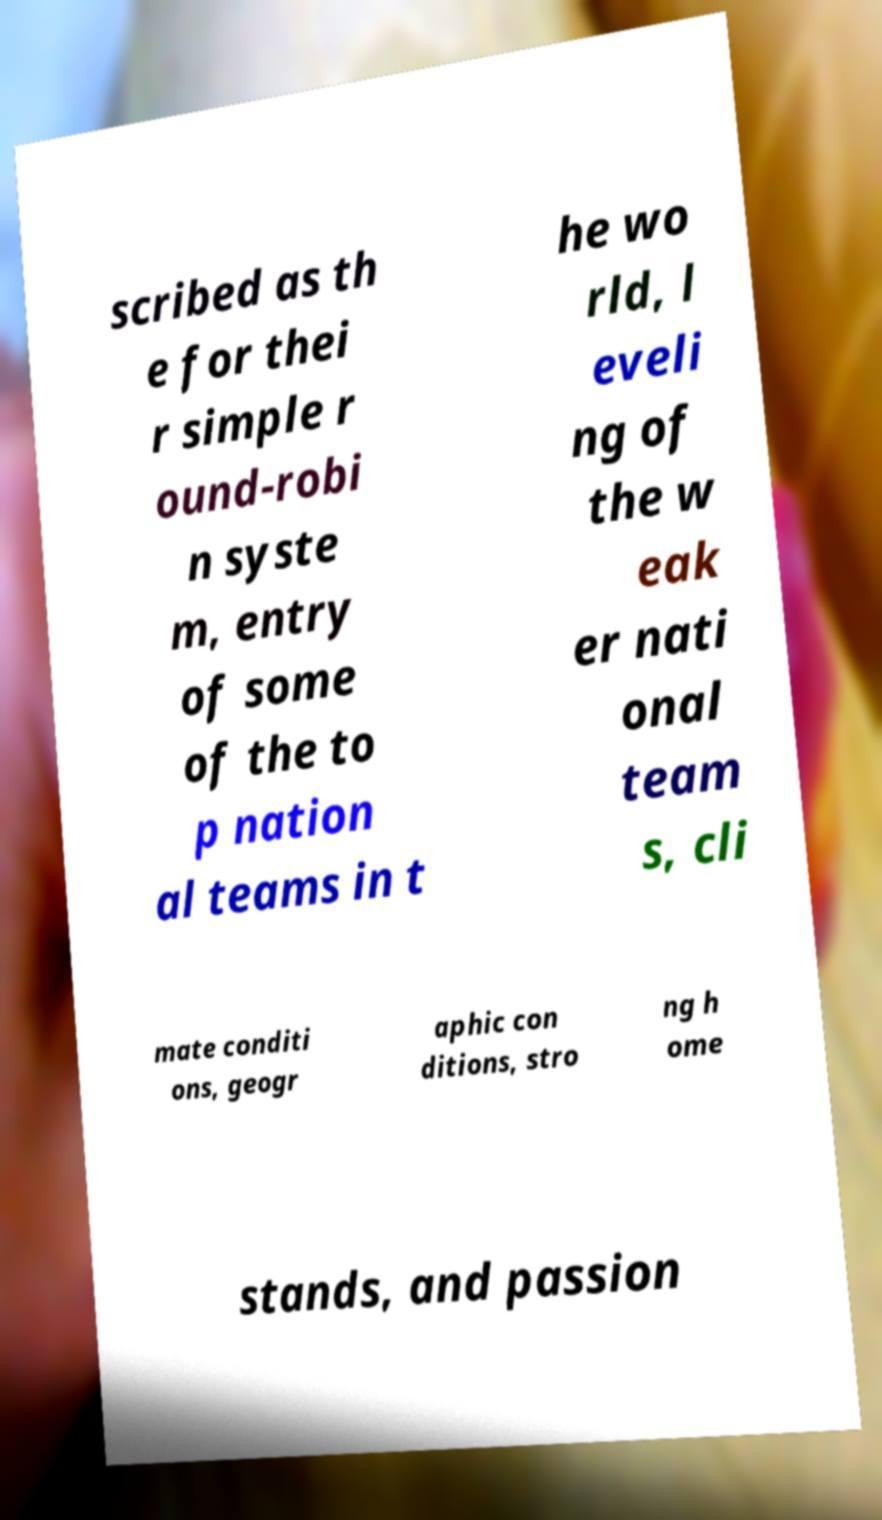Please identify and transcribe the text found in this image. scribed as th e for thei r simple r ound-robi n syste m, entry of some of the to p nation al teams in t he wo rld, l eveli ng of the w eak er nati onal team s, cli mate conditi ons, geogr aphic con ditions, stro ng h ome stands, and passion 